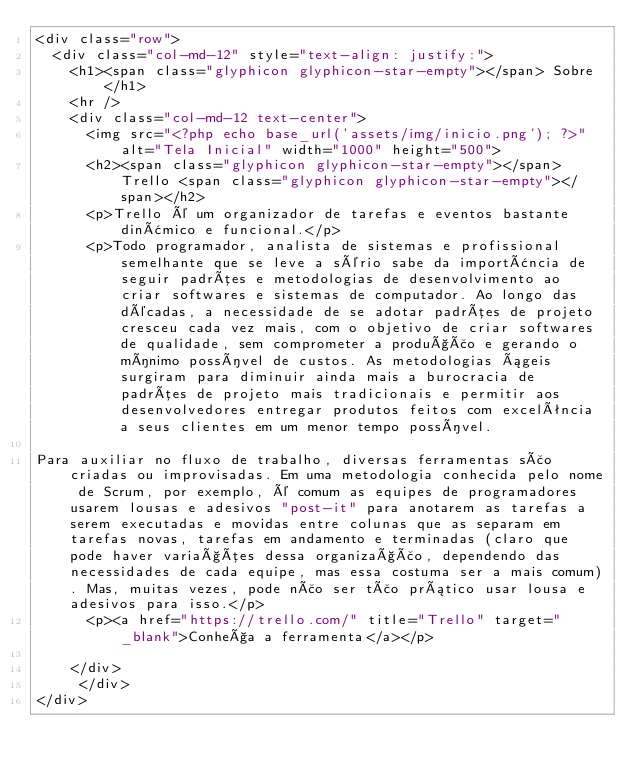<code> <loc_0><loc_0><loc_500><loc_500><_PHP_><div class="row">
  <div class="col-md-12" style="text-align: justify:">
  	<h1><span class="glyphicon glyphicon-star-empty"></span> Sobre</h1>
  	<hr />
  	<div class="col-md-12 text-center">
      <img src="<?php echo base_url('assets/img/inicio.png'); ?>" alt="Tela Inicial" width="1000" height="500">
      <h2><span class="glyphicon glyphicon-star-empty"></span> Trello <span class="glyphicon glyphicon-star-empty"></span></h2>
      <p>Trello é um organizador de tarefas e eventos bastante dinâmico e funcional.</p>
      <p>Todo programador, analista de sistemas e profissional semelhante que se leve a sério sabe da importância de seguir padrões e metodologias de desenvolvimento ao criar softwares e sistemas de computador. Ao longo das décadas, a necessidade de se adotar padrões de projeto cresceu cada vez mais, com o objetivo de criar softwares de qualidade, sem comprometer a produção e gerando o mínimo possível de custos. As metodologias ágeis surgiram para diminuir ainda mais a burocracia de padrões de projeto mais tradicionais e permitir aos desenvolvedores entregar produtos feitos com excelência a seus clientes em um menor tempo possível.

Para auxiliar no fluxo de trabalho, diversas ferramentas são criadas ou improvisadas. Em uma metodologia conhecida pelo nome de Scrum, por exemplo, é comum as equipes de programadores usarem lousas e adesivos "post-it" para anotarem as tarefas a serem executadas e movidas entre colunas que as separam em tarefas novas, tarefas em andamento e terminadas (claro que pode haver variações dessa organização, dependendo das necessidades de cada equipe, mas essa costuma ser a mais comum). Mas, muitas vezes, pode não ser tão prático usar lousa e adesivos para isso.</p>
      <p><a href="https://trello.com/" title="Trello" target="_blank">Conheça a ferramenta</a></p>
    
    </div>
     </div>
</div></code> 